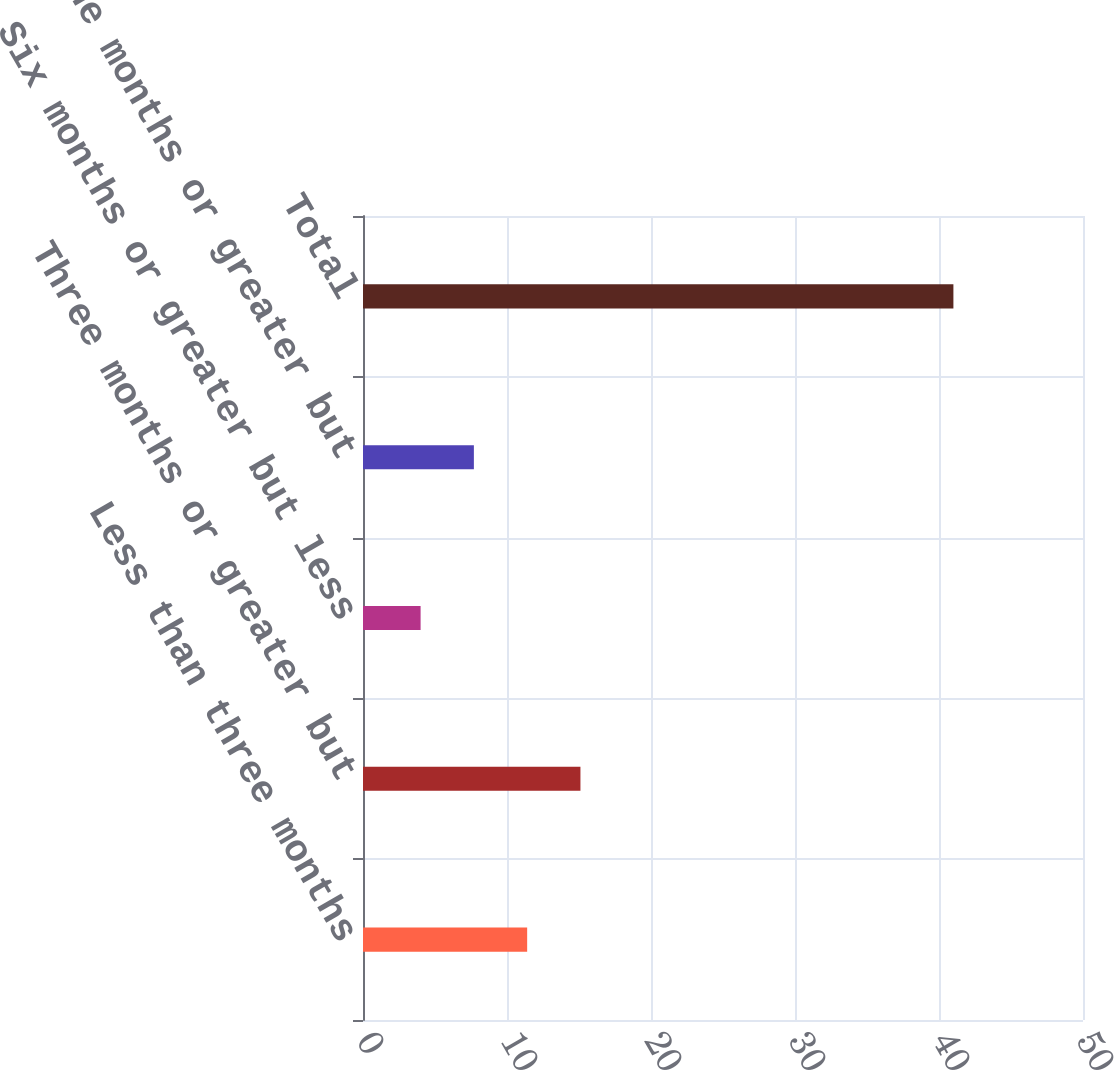<chart> <loc_0><loc_0><loc_500><loc_500><bar_chart><fcel>Less than three months<fcel>Three months or greater but<fcel>Six months or greater but less<fcel>Nine months or greater but<fcel>Total<nl><fcel>11.4<fcel>15.1<fcel>4<fcel>7.7<fcel>41<nl></chart> 